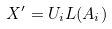<formula> <loc_0><loc_0><loc_500><loc_500>X ^ { \prime } = U _ { i } L ( A _ { i } )</formula> 